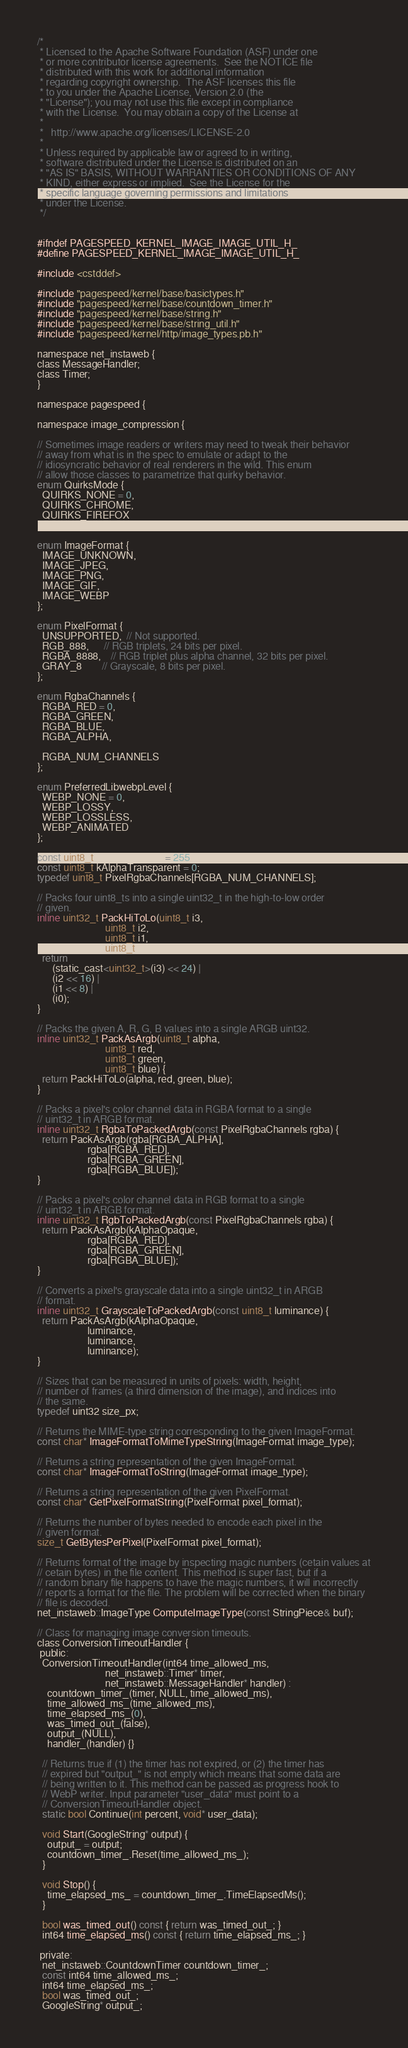<code> <loc_0><loc_0><loc_500><loc_500><_C_>/*
 * Licensed to the Apache Software Foundation (ASF) under one
 * or more contributor license agreements.  See the NOTICE file
 * distributed with this work for additional information
 * regarding copyright ownership.  The ASF licenses this file
 * to you under the Apache License, Version 2.0 (the
 * "License"); you may not use this file except in compliance
 * with the License.  You may obtain a copy of the License at
 * 
 *   http://www.apache.org/licenses/LICENSE-2.0
 * 
 * Unless required by applicable law or agreed to in writing,
 * software distributed under the License is distributed on an
 * "AS IS" BASIS, WITHOUT WARRANTIES OR CONDITIONS OF ANY
 * KIND, either express or implied.  See the License for the
 * specific language governing permissions and limitations
 * under the License.
 */


#ifndef PAGESPEED_KERNEL_IMAGE_IMAGE_UTIL_H_
#define PAGESPEED_KERNEL_IMAGE_IMAGE_UTIL_H_

#include <cstddef>

#include "pagespeed/kernel/base/basictypes.h"
#include "pagespeed/kernel/base/countdown_timer.h"
#include "pagespeed/kernel/base/string.h"
#include "pagespeed/kernel/base/string_util.h"
#include "pagespeed/kernel/http/image_types.pb.h"

namespace net_instaweb {
class MessageHandler;
class Timer;
}

namespace pagespeed {

namespace image_compression {

// Sometimes image readers or writers may need to tweak their behavior
// away from what is in the spec to emulate or adapt to the
// idiosyncratic behavior of real renderers in the wild. This enum
// allow those classes to parametrize that quirky behavior.
enum QuirksMode {
  QUIRKS_NONE = 0,
  QUIRKS_CHROME,
  QUIRKS_FIREFOX
};

enum ImageFormat {
  IMAGE_UNKNOWN,
  IMAGE_JPEG,
  IMAGE_PNG,
  IMAGE_GIF,
  IMAGE_WEBP
};

enum PixelFormat {
  UNSUPPORTED,  // Not supported.
  RGB_888,      // RGB triplets, 24 bits per pixel.
  RGBA_8888,    // RGB triplet plus alpha channel, 32 bits per pixel.
  GRAY_8        // Grayscale, 8 bits per pixel.
};

enum RgbaChannels {
  RGBA_RED = 0,
  RGBA_GREEN,
  RGBA_BLUE,
  RGBA_ALPHA,

  RGBA_NUM_CHANNELS
};

enum PreferredLibwebpLevel {
  WEBP_NONE = 0,
  WEBP_LOSSY,
  WEBP_LOSSLESS,
  WEBP_ANIMATED
};

const uint8_t kAlphaOpaque = 255;
const uint8_t kAlphaTransparent = 0;
typedef uint8_t PixelRgbaChannels[RGBA_NUM_CHANNELS];

// Packs four uint8_ts into a single uint32_t in the high-to-low order
// given.
inline uint32_t PackHiToLo(uint8_t i3,
                           uint8_t i2,
                           uint8_t i1,
                           uint8_t i0) {
  return
      (static_cast<uint32_t>(i3) << 24) |
      (i2 << 16) |
      (i1 << 8) |
      (i0);
}

// Packs the given A, R, G, B values into a single ARGB uint32.
inline uint32_t PackAsArgb(uint8_t alpha,
                           uint8_t red,
                           uint8_t green,
                           uint8_t blue) {
  return PackHiToLo(alpha, red, green, blue);
}

// Packs a pixel's color channel data in RGBA format to a single
// uint32_t in ARGB format.
inline uint32_t RgbaToPackedArgb(const PixelRgbaChannels rgba) {
  return PackAsArgb(rgba[RGBA_ALPHA],
                    rgba[RGBA_RED],
                    rgba[RGBA_GREEN],
                    rgba[RGBA_BLUE]);
}

// Packs a pixel's color channel data in RGB format to a single
// uint32_t in ARGB format.
inline uint32_t RgbToPackedArgb(const PixelRgbaChannels rgba) {
  return PackAsArgb(kAlphaOpaque,
                    rgba[RGBA_RED],
                    rgba[RGBA_GREEN],
                    rgba[RGBA_BLUE]);
}

// Converts a pixel's grayscale data into a single uint32_t in ARGB
// format.
inline uint32_t GrayscaleToPackedArgb(const uint8_t luminance) {
  return PackAsArgb(kAlphaOpaque,
                    luminance,
                    luminance,
                    luminance);
}

// Sizes that can be measured in units of pixels: width, height,
// number of frames (a third dimension of the image), and indices into
// the same.
typedef uint32 size_px;

// Returns the MIME-type string corresponding to the given ImageFormat.
const char* ImageFormatToMimeTypeString(ImageFormat image_type);

// Returns a string representation of the given ImageFormat.
const char* ImageFormatToString(ImageFormat image_type);

// Returns a string representation of the given PixelFormat.
const char* GetPixelFormatString(PixelFormat pixel_format);

// Returns the number of bytes needed to encode each pixel in the
// given format.
size_t GetBytesPerPixel(PixelFormat pixel_format);

// Returns format of the image by inspecting magic numbers (cetain values at
// cetain bytes) in the file content. This method is super fast, but if a
// random binary file happens to have the magic numbers, it will incorrectly
// reports a format for the file. The problem will be corrected when the binary
// file is decoded.
net_instaweb::ImageType ComputeImageType(const StringPiece& buf);

// Class for managing image conversion timeouts.
class ConversionTimeoutHandler {
 public:
  ConversionTimeoutHandler(int64 time_allowed_ms,
                           net_instaweb::Timer* timer,
                           net_instaweb::MessageHandler* handler) :
    countdown_timer_(timer, NULL, time_allowed_ms),
    time_allowed_ms_(time_allowed_ms),
    time_elapsed_ms_(0),
    was_timed_out_(false),
    output_(NULL),
    handler_(handler) {}

  // Returns true if (1) the timer has not expired, or (2) the timer has
  // expired but "output_" is not empty which means that some data are
  // being written to it. This method can be passed as progress hook to
  // WebP writer. Input parameter "user_data" must point to a
  // ConversionTimeoutHandler object.
  static bool Continue(int percent, void* user_data);

  void Start(GoogleString* output) {
    output_ = output;
    countdown_timer_.Reset(time_allowed_ms_);
  }

  void Stop() {
    time_elapsed_ms_ = countdown_timer_.TimeElapsedMs();
  }

  bool was_timed_out() const { return was_timed_out_; }
  int64 time_elapsed_ms() const { return time_elapsed_ms_; }

 private:
  net_instaweb::CountdownTimer countdown_timer_;
  const int64 time_allowed_ms_;
  int64 time_elapsed_ms_;
  bool was_timed_out_;
  GoogleString* output_;</code> 